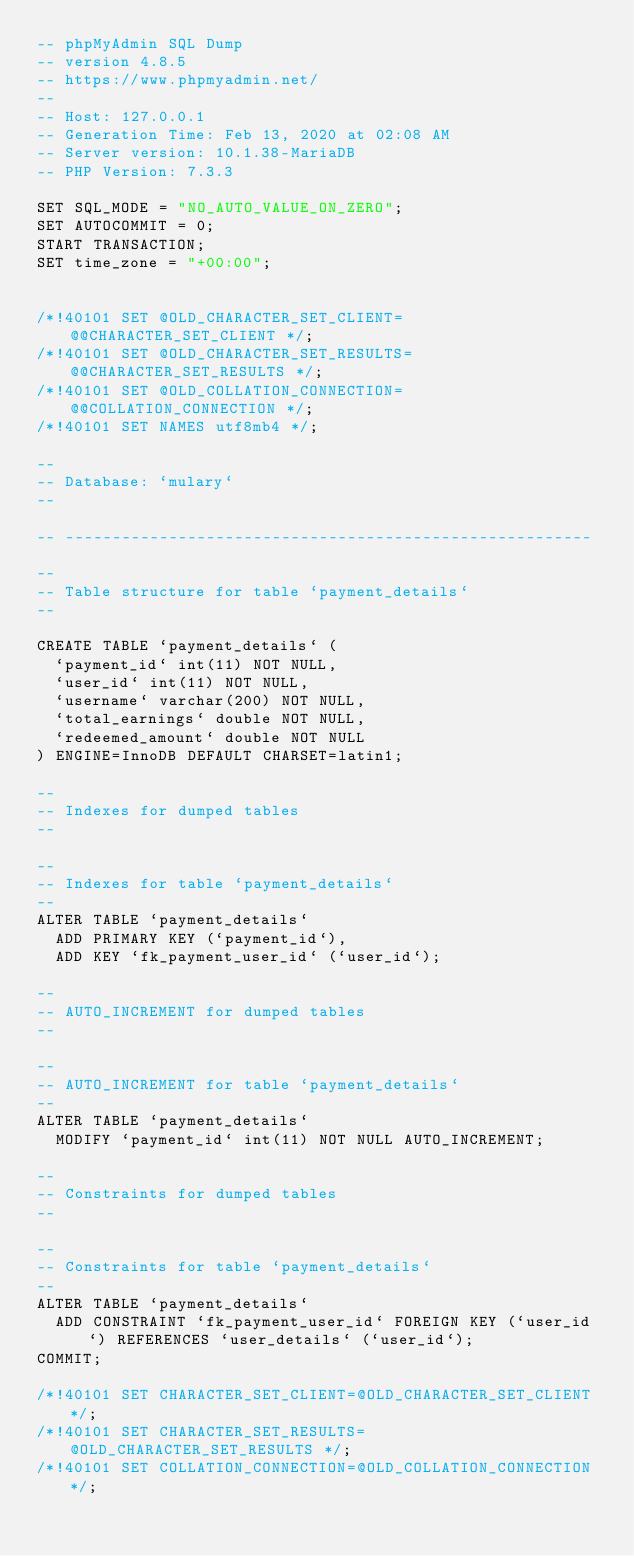<code> <loc_0><loc_0><loc_500><loc_500><_SQL_>-- phpMyAdmin SQL Dump
-- version 4.8.5
-- https://www.phpmyadmin.net/
--
-- Host: 127.0.0.1
-- Generation Time: Feb 13, 2020 at 02:08 AM
-- Server version: 10.1.38-MariaDB
-- PHP Version: 7.3.3

SET SQL_MODE = "NO_AUTO_VALUE_ON_ZERO";
SET AUTOCOMMIT = 0;
START TRANSACTION;
SET time_zone = "+00:00";


/*!40101 SET @OLD_CHARACTER_SET_CLIENT=@@CHARACTER_SET_CLIENT */;
/*!40101 SET @OLD_CHARACTER_SET_RESULTS=@@CHARACTER_SET_RESULTS */;
/*!40101 SET @OLD_COLLATION_CONNECTION=@@COLLATION_CONNECTION */;
/*!40101 SET NAMES utf8mb4 */;

--
-- Database: `mulary`
--

-- --------------------------------------------------------

--
-- Table structure for table `payment_details`
--

CREATE TABLE `payment_details` (
  `payment_id` int(11) NOT NULL,
  `user_id` int(11) NOT NULL,
  `username` varchar(200) NOT NULL,
  `total_earnings` double NOT NULL,
  `redeemed_amount` double NOT NULL
) ENGINE=InnoDB DEFAULT CHARSET=latin1;

--
-- Indexes for dumped tables
--

--
-- Indexes for table `payment_details`
--
ALTER TABLE `payment_details`
  ADD PRIMARY KEY (`payment_id`),
  ADD KEY `fk_payment_user_id` (`user_id`);

--
-- AUTO_INCREMENT for dumped tables
--

--
-- AUTO_INCREMENT for table `payment_details`
--
ALTER TABLE `payment_details`
  MODIFY `payment_id` int(11) NOT NULL AUTO_INCREMENT;

--
-- Constraints for dumped tables
--

--
-- Constraints for table `payment_details`
--
ALTER TABLE `payment_details`
  ADD CONSTRAINT `fk_payment_user_id` FOREIGN KEY (`user_id`) REFERENCES `user_details` (`user_id`);
COMMIT;

/*!40101 SET CHARACTER_SET_CLIENT=@OLD_CHARACTER_SET_CLIENT */;
/*!40101 SET CHARACTER_SET_RESULTS=@OLD_CHARACTER_SET_RESULTS */;
/*!40101 SET COLLATION_CONNECTION=@OLD_COLLATION_CONNECTION */;
</code> 